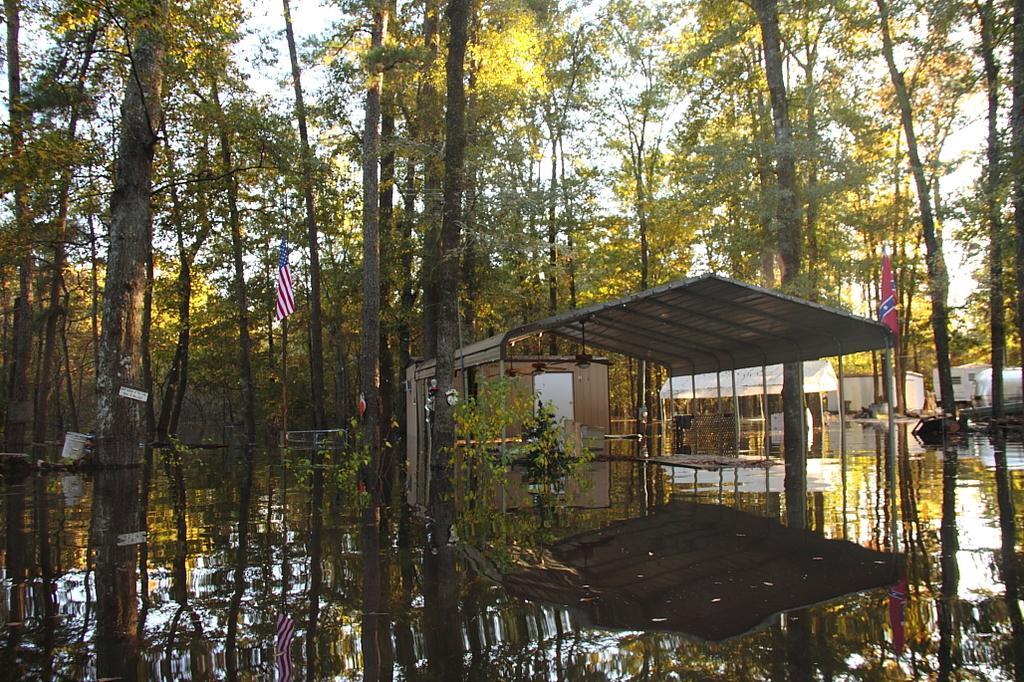In one or two sentences, can you explain what this image depicts? In this image I can see trees, shed and water also there are some flags on the shed. 